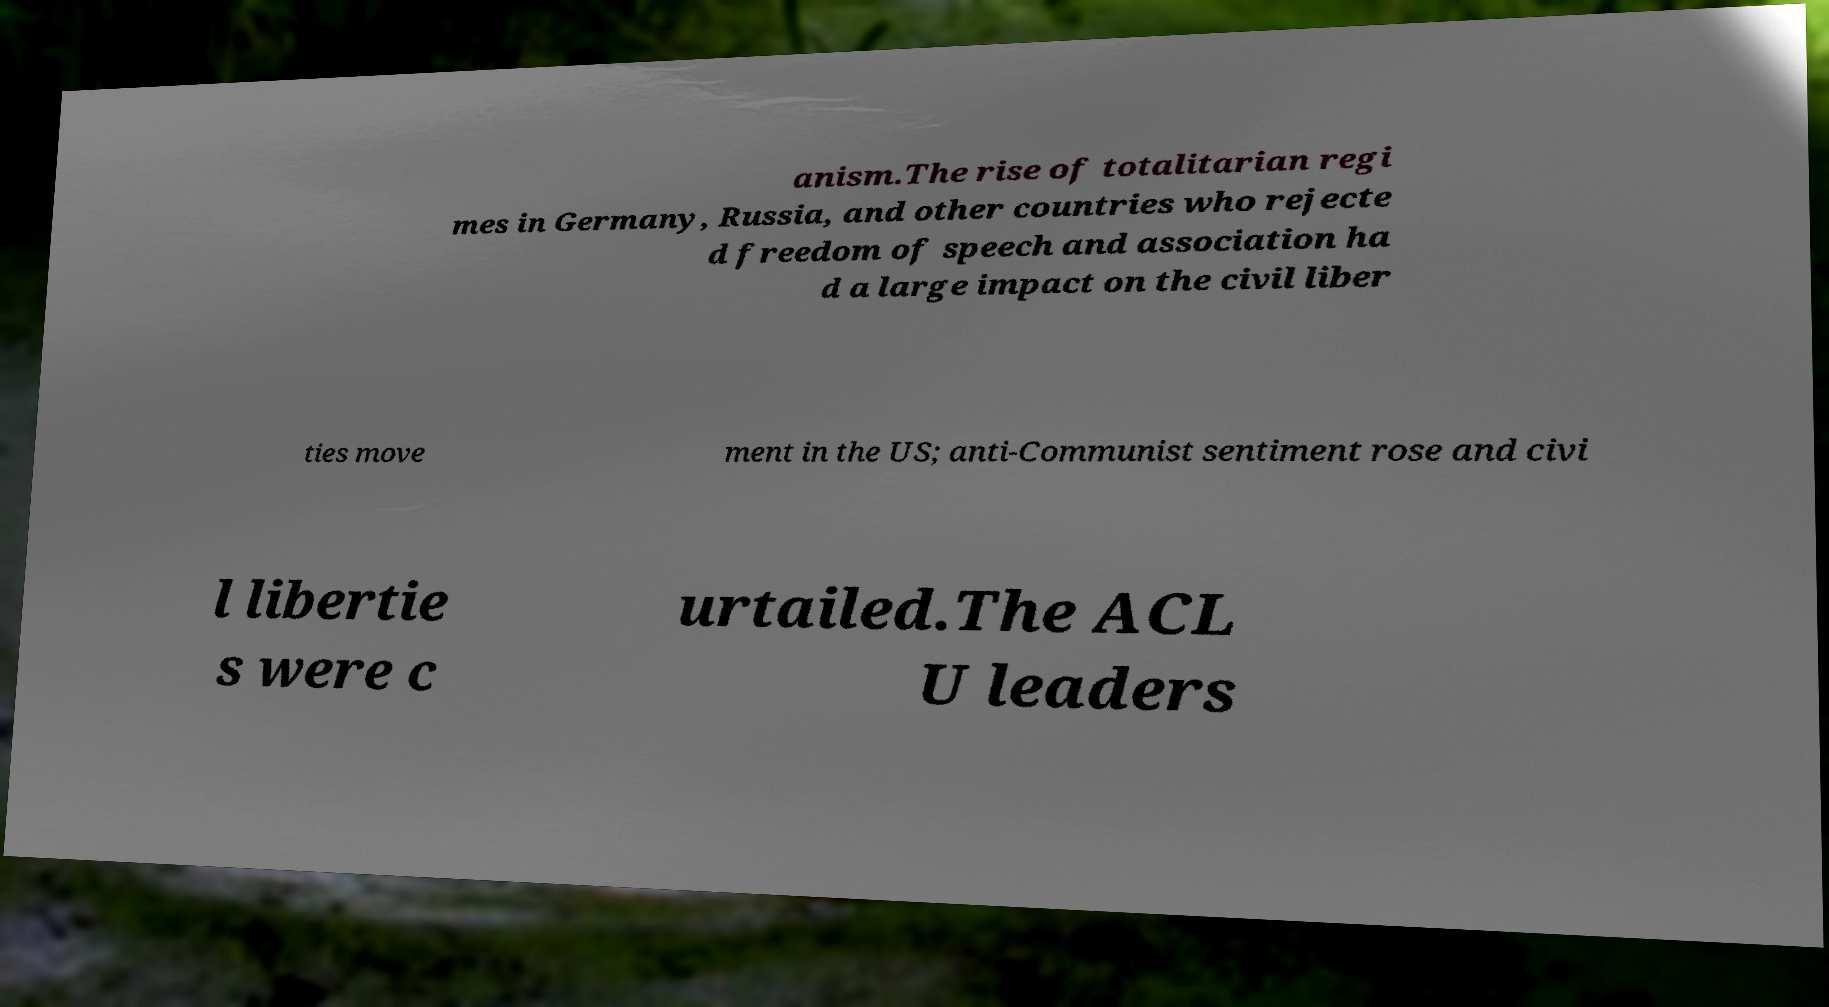There's text embedded in this image that I need extracted. Can you transcribe it verbatim? anism.The rise of totalitarian regi mes in Germany, Russia, and other countries who rejecte d freedom of speech and association ha d a large impact on the civil liber ties move ment in the US; anti-Communist sentiment rose and civi l libertie s were c urtailed.The ACL U leaders 